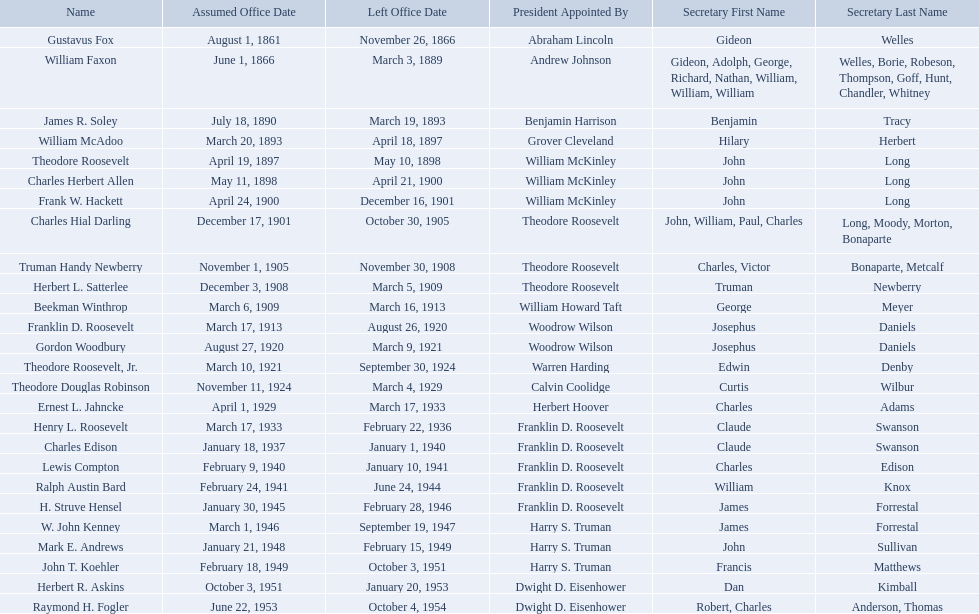Who were all the assistant secretary's of the navy? Gustavus Fox, William Faxon, James R. Soley, William McAdoo, Theodore Roosevelt, Charles Herbert Allen, Frank W. Hackett, Charles Hial Darling, Truman Handy Newberry, Herbert L. Satterlee, Beekman Winthrop, Franklin D. Roosevelt, Gordon Woodbury, Theodore Roosevelt, Jr., Theodore Douglas Robinson, Ernest L. Jahncke, Henry L. Roosevelt, Charles Edison, Lewis Compton, Ralph Austin Bard, H. Struve Hensel, W. John Kenney, Mark E. Andrews, John T. Koehler, Herbert R. Askins, Raymond H. Fogler. What are the various dates they left office in? November 26, 1866, March 3, 1889, March 19, 1893, April 18, 1897, May 10, 1898, April 21, 1900, December 16, 1901, October 30, 1905, November 30, 1908, March 5, 1909, March 16, 1913, August 26, 1920, March 9, 1921, September 30, 1924, March 4, 1929, March 17, 1933, February 22, 1936, January 1, 1940, January 10, 1941, June 24, 1944, February 28, 1946, September 19, 1947, February 15, 1949, October 3, 1951, January 20, 1953, October 4, 1954. Of these dates, which was the date raymond h. fogler left office in? October 4, 1954. Who are all of the assistant secretaries of the navy in the 20th century? Charles Herbert Allen, Frank W. Hackett, Charles Hial Darling, Truman Handy Newberry, Herbert L. Satterlee, Beekman Winthrop, Franklin D. Roosevelt, Gordon Woodbury, Theodore Roosevelt, Jr., Theodore Douglas Robinson, Ernest L. Jahncke, Henry L. Roosevelt, Charles Edison, Lewis Compton, Ralph Austin Bard, H. Struve Hensel, W. John Kenney, Mark E. Andrews, John T. Koehler, Herbert R. Askins, Raymond H. Fogler. What date was assistant secretary of the navy raymond h. fogler appointed? June 22, 1953. What date did assistant secretary of the navy raymond h. fogler leave office? October 4, 1954. 